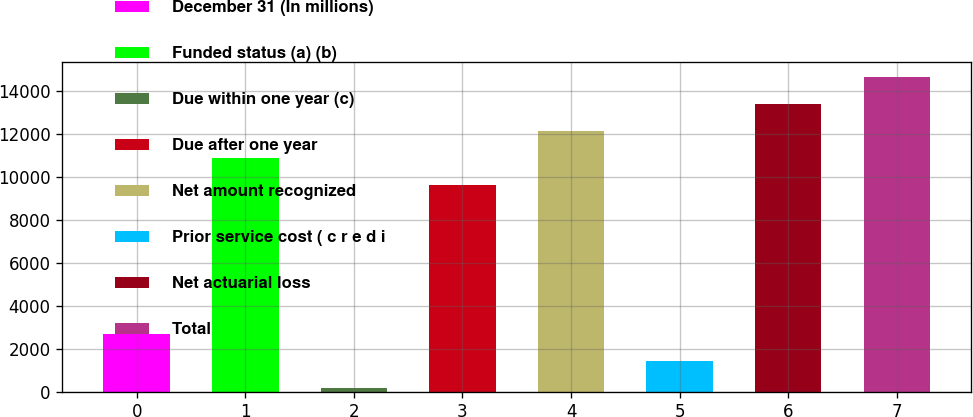<chart> <loc_0><loc_0><loc_500><loc_500><bar_chart><fcel>December 31 (In millions)<fcel>Funded status (a) (b)<fcel>Due within one year (c)<fcel>Due after one year<fcel>Net amount recognized<fcel>Prior service cost ( c r e d i<fcel>Net actuarial loss<fcel>Total<nl><fcel>2679<fcel>10900.5<fcel>170<fcel>9646<fcel>12155<fcel>1424.5<fcel>13409.5<fcel>14664<nl></chart> 